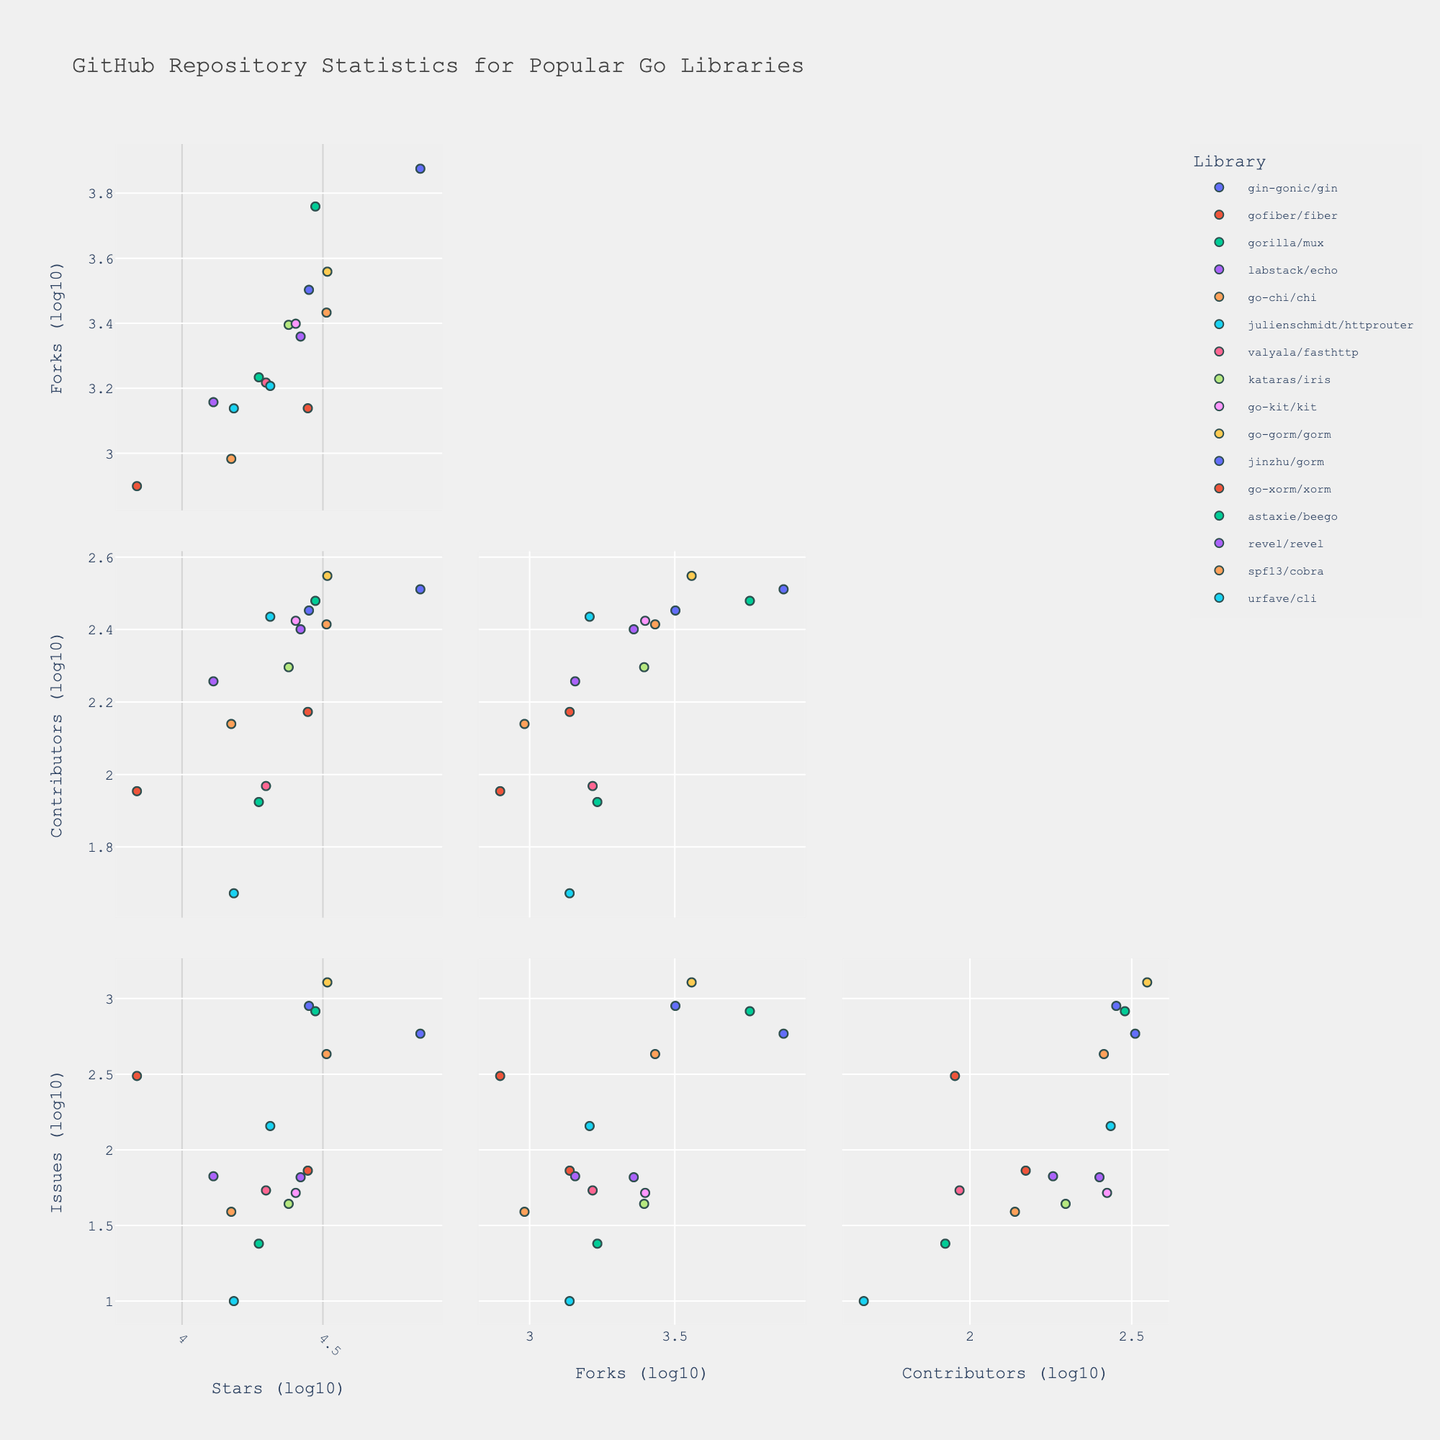What is the general trend between Stars and Forks? By examining the scatterplot matrix, it can be observed that there is a positive correlation between Stars and Forks. As the number of stars increases, so does the number of forks.
Answer: Positive correlation Which repository has the highest number of contributors? Look for the highest point on the Contributors axis across all repositories. This point belongs to go-gorm/gorm.
Answer: go-gorm/gorm Is there a strong correlation between Contributors and Issues? By observing the scatterplot matrix, it seems that the correlation between Contributors and Issues is not very strong. The data points are more scattered, indicating a weaker relationship.
Answer: Weak correlation Which library has the highest Issues relative to its number of stars? By comparing the Issues and Stars for each library, go-gorm/gorm appears to have the highest number of issues relative to its number of stars.
Answer: go-gorm/gorm How do the number of stars for 'gin-gonic/gin' compare to 'revel/revel'? 'gin-gonic/gin' has significantly more stars compared to 'revel/revel'. The data point for 'gin-gonic/gin' is much higher on the Stars axis than that of 'revel/revel'.
Answer: gin-gonic/gin > revel/revel Does 'go-chi/chi' have more forks or contributors? Referring to the scatterplot matrix, the point for 'go-chi/chi' is higher on the Contributors axis than on the Forks axis. This indicates that it has more contributors than forks.
Answer: Contributors > Forks Which repository has the lowest number of issues? By identifying the lowest data point on the Issues axis, it can be observed that julienschmidt/httprouter has the lowest number of issues.
Answer: julienschmidt/httprouter What do the axes represent in the scatterplot matrix? The axes in the scatterplot matrix represent the logarithm (base 10) of the numeric values of Stars, Forks, Contributors, and Issues for various libraries.
Answer: Logarithm of Stars, Forks, Contributors, Issues Which has more contributors, 'labstack/echo' or 'gofiber/fiber'? By comparing the positions of 'labstack/echo' and 'gofiber/fiber' on the Contributors axis, 'labstack/echo' has more contributors.
Answer: labstack/echo 